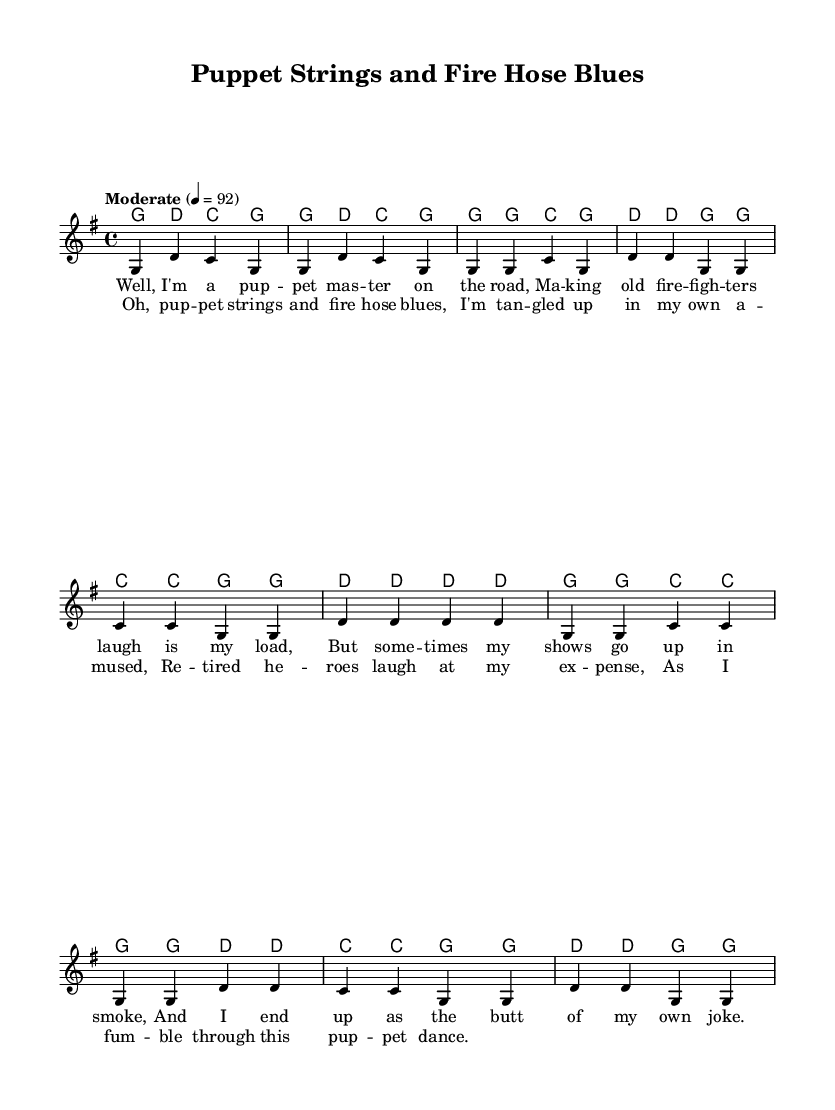What is the key signature of this music? The key signature is G major, which has one sharp (F#). This can be determined from the global section of the code where it specifies "\key g \major".
Answer: G major What is the time signature of this music? The time signature is 4/4, indicating four beats in a measure. This is stated in the global section of the code with "\time 4/4".
Answer: 4/4 What is the tempo marking indicated in the sheet music? The tempo marking is "Moderate" at a speed of 92 beats per minute. This is indicated in the global section as "\tempo 'Moderate' 4 = 92".
Answer: Moderate 92 What is the repeated phrase in the chorus? The repeated phrase in the chorus is "pup -- pet strings and fire hose blues," which directly correlates to the lyric structure shown under the chorus section of the code.
Answer: pup -- pet strings and fire hose blues What type of humor is reflected in the lyrics of the song? The lyrics reflect self-deprecating humor, as the puppeteer humorously recounts misadventures that lead to laughter from retired firefighters, which can be inferred from the themes presented in the verse and chorus.
Answer: Self-deprecating humor What is the overall theme of the ballad? The overall theme of the ballad is the misadventures of a traveling puppeteer, as evidenced by the expressions of humor and mishaps in both the verse and chorus lyrics.
Answer: Misadventures of a traveling puppeteer 